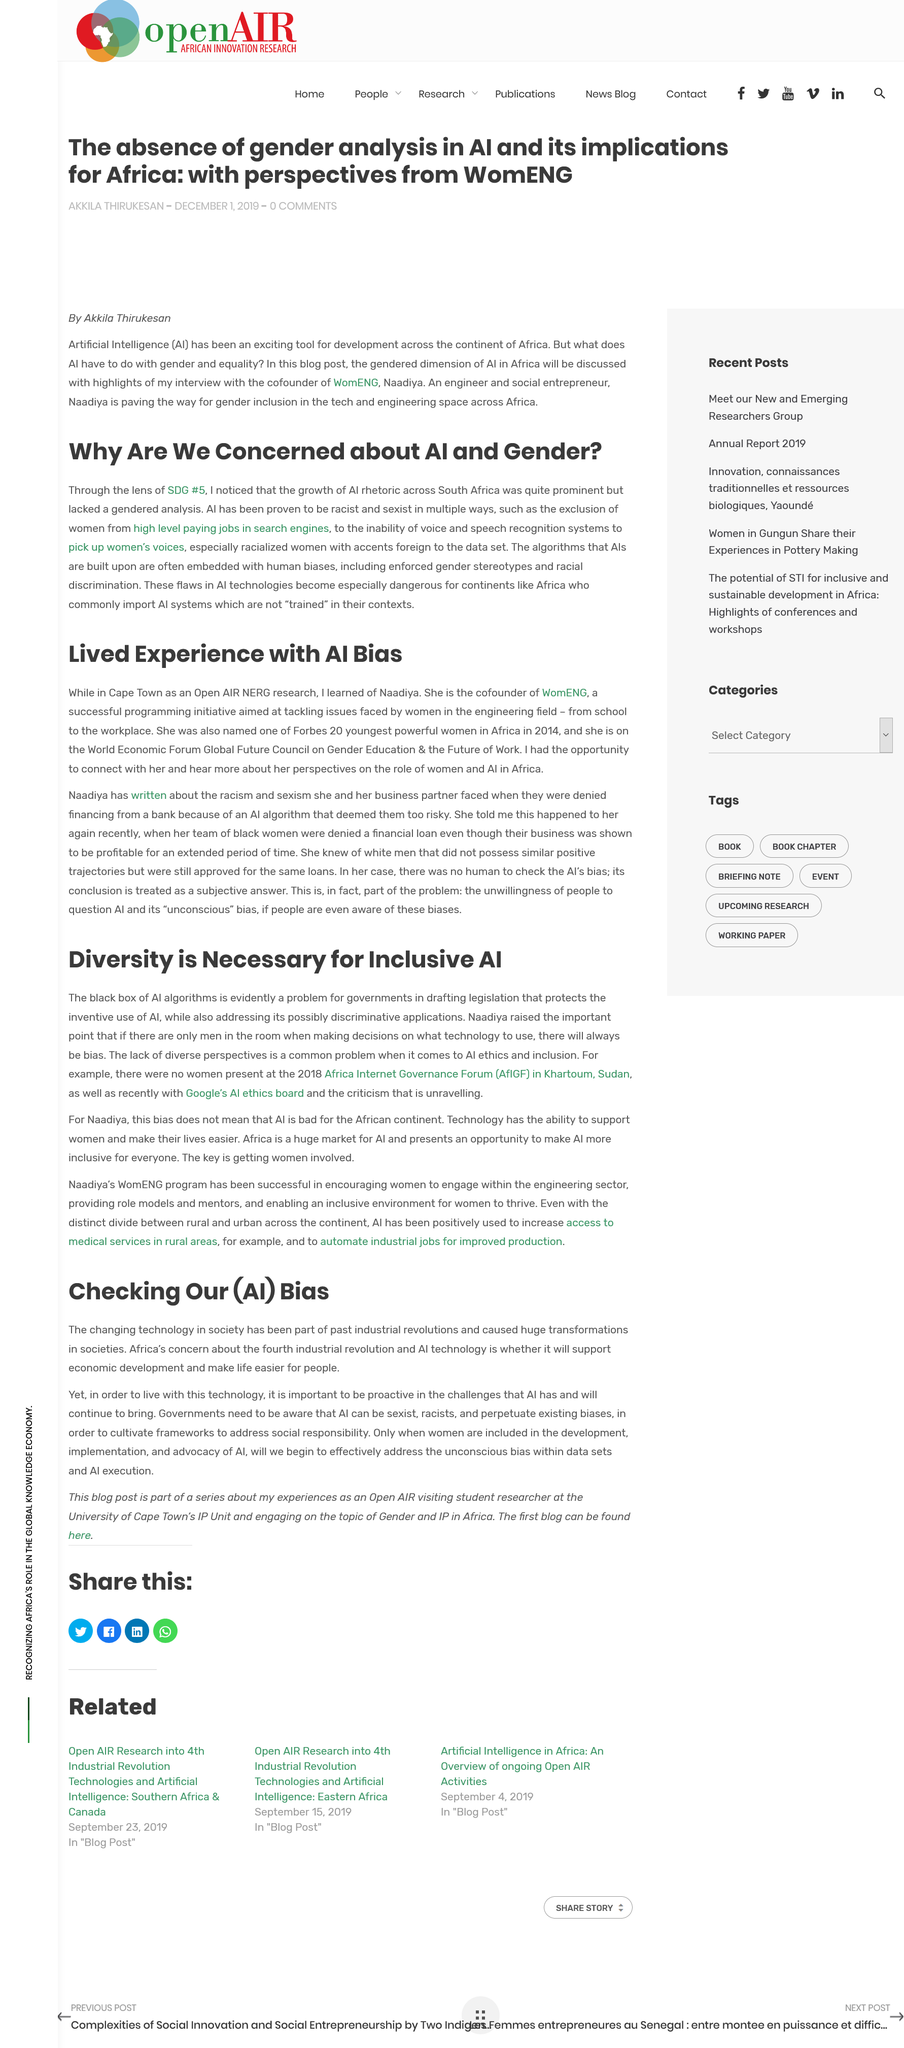Draw attention to some important aspects in this diagram. The AI has been proven to be racist and sexist in multiple ways, including excluding women from high-level playing jobs in search engines, and being incompetent in voice and speech recognition systems, resulting in the inability to pick up on the voices and speech patterns of women, particularly those with foreign accents. A common problem in AI ethics and inclusion is the lack of diverse perspectives, which can lead to biased and unfair outcomes. According to the article "Checking Our (AI) Bias", Africa's primary concern about the fourth industrial revolution and AI is whether it will promote economic growth and improve the standard of living for its people. It is crucial that women be included in the development of AI to address unconscious bias within data sets and AI execution and ensure that AI reflects and benefits all individuals. Drafting legislation that protects the inventive use of AI while addressing the concerns of the black box nature of AI algorithms and its potential for discriminatory applications is a challenging task for governments. 